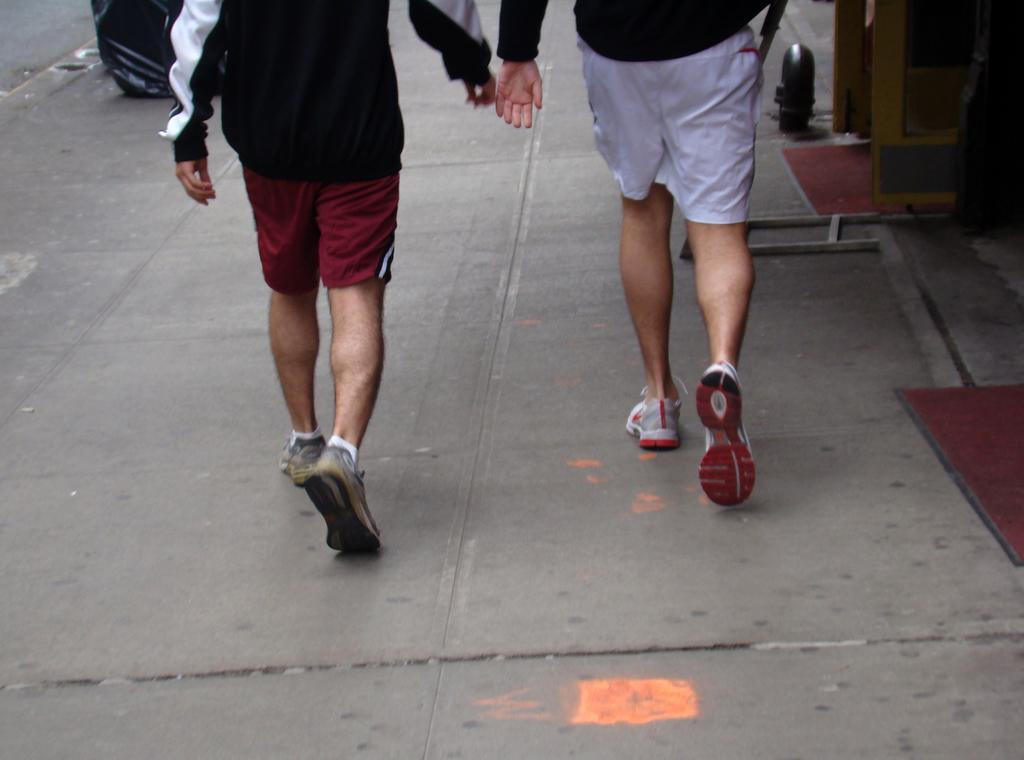How many people are in the image? There are two people in the image. What are the two people doing in the image? The two people are walking. Can you describe any objects present in the image? Unfortunately, the provided facts do not mention any specific objects in the image. What type of stocking is the minister wearing in the image? There is no minister or stocking present in the image. How is the wax being used in the image? There is no wax present in the image. 